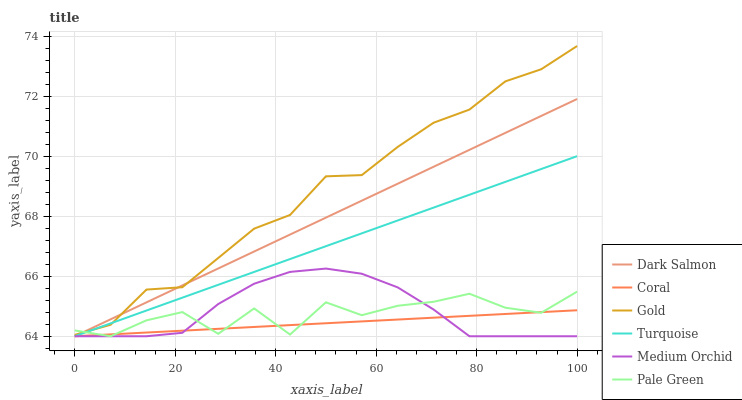Does Coral have the minimum area under the curve?
Answer yes or no. Yes. Does Gold have the maximum area under the curve?
Answer yes or no. Yes. Does Gold have the minimum area under the curve?
Answer yes or no. No. Does Coral have the maximum area under the curve?
Answer yes or no. No. Is Turquoise the smoothest?
Answer yes or no. Yes. Is Pale Green the roughest?
Answer yes or no. Yes. Is Gold the smoothest?
Answer yes or no. No. Is Gold the roughest?
Answer yes or no. No. Does Turquoise have the lowest value?
Answer yes or no. Yes. Does Gold have the lowest value?
Answer yes or no. No. Does Gold have the highest value?
Answer yes or no. Yes. Does Coral have the highest value?
Answer yes or no. No. Is Medium Orchid less than Gold?
Answer yes or no. Yes. Is Gold greater than Medium Orchid?
Answer yes or no. Yes. Does Medium Orchid intersect Coral?
Answer yes or no. Yes. Is Medium Orchid less than Coral?
Answer yes or no. No. Is Medium Orchid greater than Coral?
Answer yes or no. No. Does Medium Orchid intersect Gold?
Answer yes or no. No. 